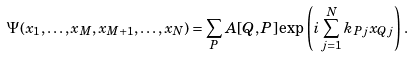<formula> <loc_0><loc_0><loc_500><loc_500>\Psi ( x _ { 1 } , \dots , x _ { M } , x _ { M + 1 } , \dots , x _ { N } ) = \sum _ { P } A [ Q , P ] \exp \left ( i \sum _ { j = 1 } ^ { N } k _ { P j } x _ { Q j } \right ) \, .</formula> 